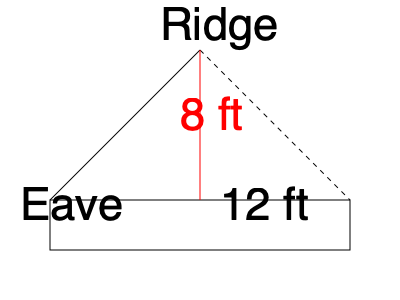As a contractor, you're designing a roof for a new outdoor structure. The roof has a rise of 8 feet and a run of 12 feet. Calculate the slope of the roof, expressing it as a ratio in its simplest form. To calculate the slope of a roof, we need to follow these steps:

1. Identify the rise and run:
   Rise = 8 feet
   Run = 12 feet

2. The slope is expressed as the ratio of rise to run:
   Slope = Rise : Run
   Slope = 8 : 12

3. Simplify the ratio by dividing both numbers by their greatest common divisor (GCD):
   GCD of 8 and 12 is 4
   
   Simplified slope = (8 ÷ 4) : (12 ÷ 4)
                    = 2 : 3

4. Express the slope as a ratio:
   Slope = 2:3

In roofing terms, this is often referred to as a "2 in 12" pitch, meaning the roof rises 2 units for every 12 units of horizontal distance.
Answer: 2:3 